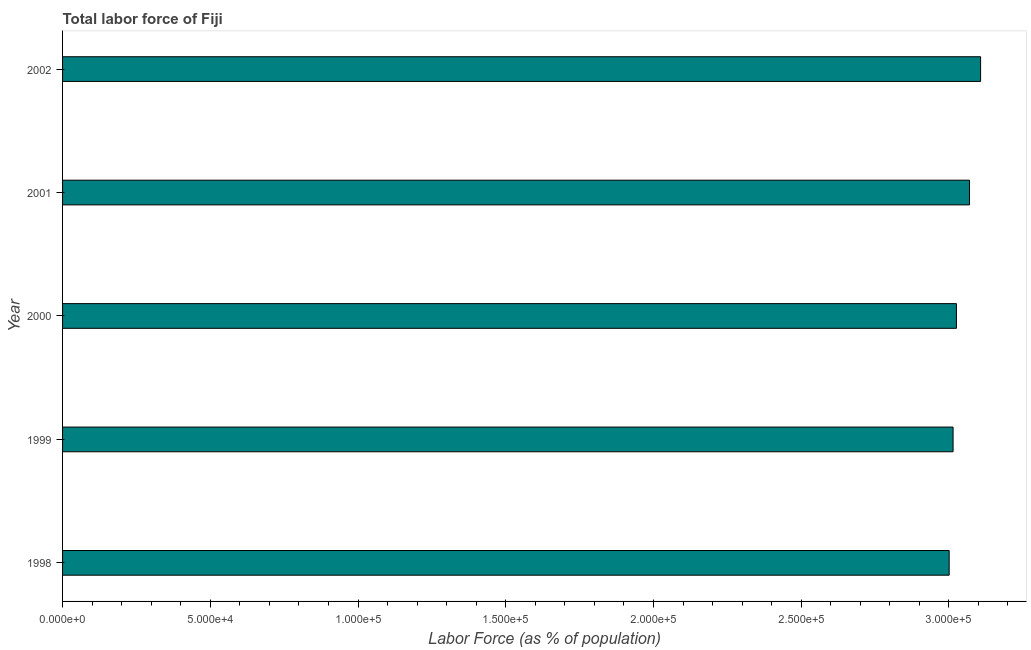Does the graph contain any zero values?
Give a very brief answer. No. Does the graph contain grids?
Offer a very short reply. No. What is the title of the graph?
Provide a succinct answer. Total labor force of Fiji. What is the label or title of the X-axis?
Offer a very short reply. Labor Force (as % of population). What is the total labor force in 1999?
Keep it short and to the point. 3.01e+05. Across all years, what is the maximum total labor force?
Your answer should be compact. 3.11e+05. Across all years, what is the minimum total labor force?
Offer a very short reply. 3.00e+05. What is the sum of the total labor force?
Provide a succinct answer. 1.52e+06. What is the difference between the total labor force in 2001 and 2002?
Ensure brevity in your answer.  -3749. What is the average total labor force per year?
Your answer should be compact. 3.04e+05. What is the median total labor force?
Offer a very short reply. 3.03e+05. In how many years, is the total labor force greater than 60000 %?
Your answer should be compact. 5. Do a majority of the years between 1998 and 2000 (inclusive) have total labor force greater than 110000 %?
Ensure brevity in your answer.  Yes. Is the total labor force in 2001 less than that in 2002?
Your response must be concise. Yes. What is the difference between the highest and the second highest total labor force?
Keep it short and to the point. 3749. Is the sum of the total labor force in 2001 and 2002 greater than the maximum total labor force across all years?
Give a very brief answer. Yes. What is the difference between the highest and the lowest total labor force?
Ensure brevity in your answer.  1.06e+04. In how many years, is the total labor force greater than the average total labor force taken over all years?
Offer a very short reply. 2. How many bars are there?
Provide a succinct answer. 5. How many years are there in the graph?
Offer a terse response. 5. What is the difference between two consecutive major ticks on the X-axis?
Give a very brief answer. 5.00e+04. What is the Labor Force (as % of population) in 1998?
Provide a succinct answer. 3.00e+05. What is the Labor Force (as % of population) in 1999?
Your answer should be compact. 3.01e+05. What is the Labor Force (as % of population) in 2000?
Offer a terse response. 3.03e+05. What is the Labor Force (as % of population) in 2001?
Ensure brevity in your answer.  3.07e+05. What is the Labor Force (as % of population) of 2002?
Your response must be concise. 3.11e+05. What is the difference between the Labor Force (as % of population) in 1998 and 1999?
Offer a terse response. -1322. What is the difference between the Labor Force (as % of population) in 1998 and 2000?
Give a very brief answer. -2455. What is the difference between the Labor Force (as % of population) in 1998 and 2001?
Keep it short and to the point. -6887. What is the difference between the Labor Force (as % of population) in 1998 and 2002?
Offer a very short reply. -1.06e+04. What is the difference between the Labor Force (as % of population) in 1999 and 2000?
Keep it short and to the point. -1133. What is the difference between the Labor Force (as % of population) in 1999 and 2001?
Make the answer very short. -5565. What is the difference between the Labor Force (as % of population) in 1999 and 2002?
Keep it short and to the point. -9314. What is the difference between the Labor Force (as % of population) in 2000 and 2001?
Your response must be concise. -4432. What is the difference between the Labor Force (as % of population) in 2000 and 2002?
Give a very brief answer. -8181. What is the difference between the Labor Force (as % of population) in 2001 and 2002?
Keep it short and to the point. -3749. What is the ratio of the Labor Force (as % of population) in 1998 to that in 2000?
Your answer should be very brief. 0.99. What is the ratio of the Labor Force (as % of population) in 1999 to that in 2001?
Offer a very short reply. 0.98. What is the ratio of the Labor Force (as % of population) in 1999 to that in 2002?
Your answer should be very brief. 0.97. What is the ratio of the Labor Force (as % of population) in 2000 to that in 2001?
Your answer should be compact. 0.99. What is the ratio of the Labor Force (as % of population) in 2001 to that in 2002?
Your answer should be very brief. 0.99. 